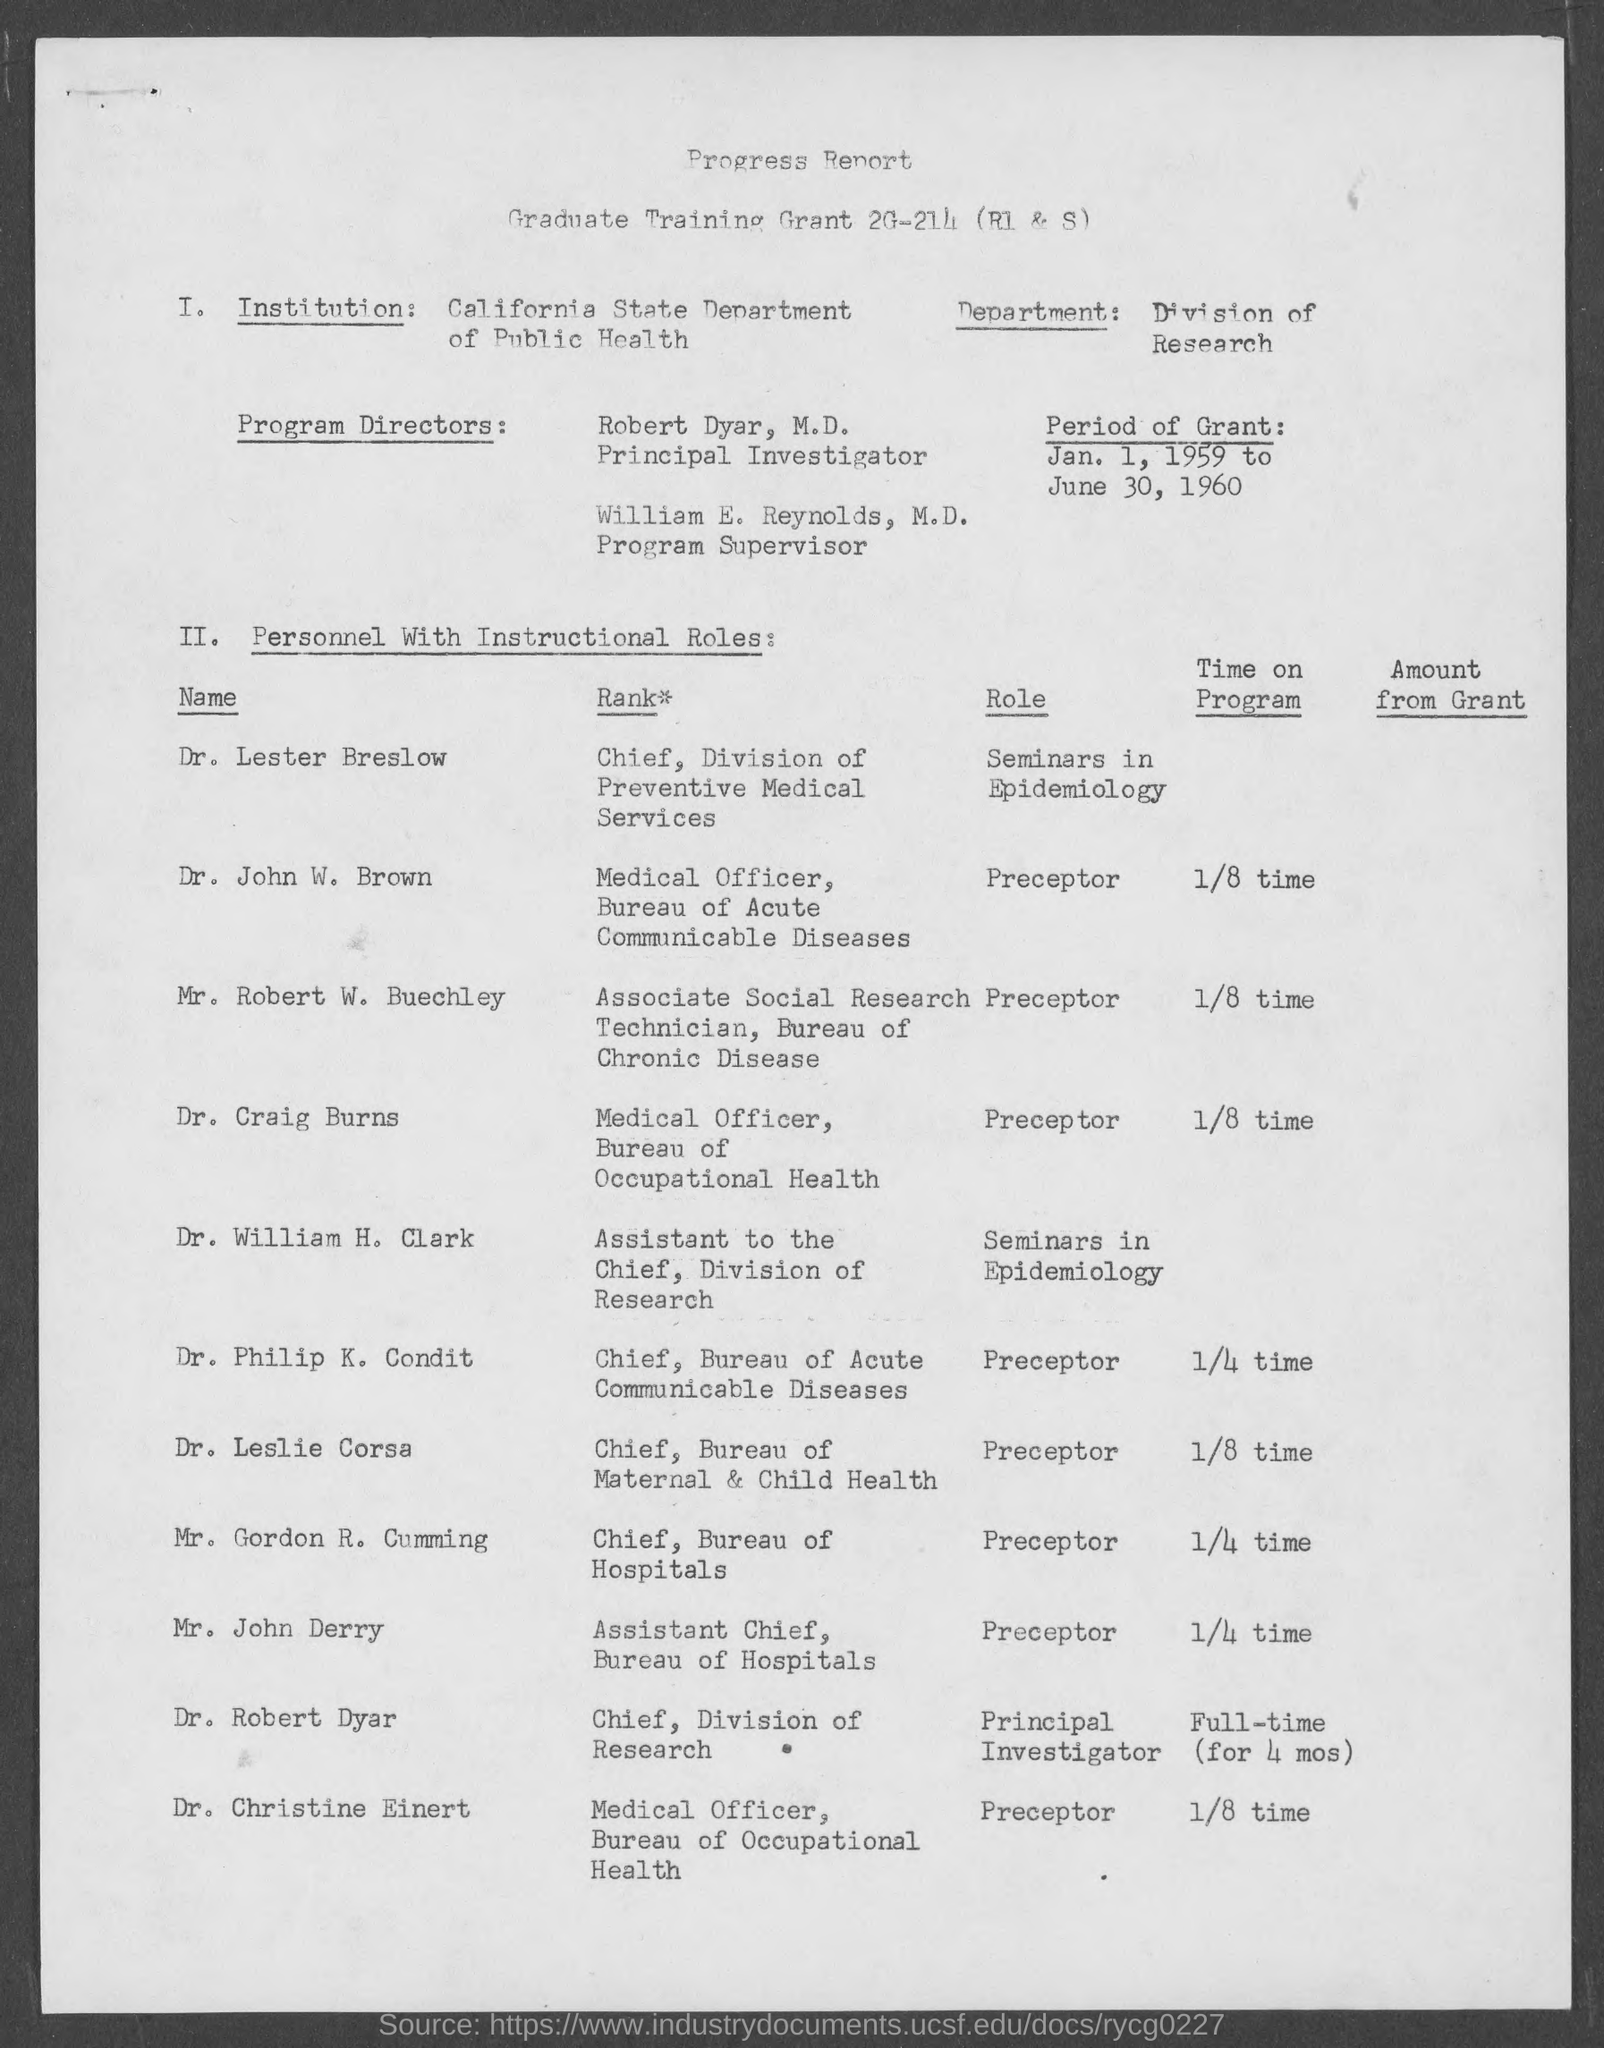Which institution is mentioned in this document?
Provide a succinct answer. CALIFORNIA STATE DEPARTMENT OF PUBLIC HEALTH. Which department is mentioned in this document?
Give a very brief answer. DIVISION OF RESEARCH. What is the period of Grant given in the document?
Your answer should be compact. JAN. 1, 1959 TO JUNE 30, 1960. Who is the Principal Investigator as per the document?
Ensure brevity in your answer.  ROBERT DYAR. Who is the Program Supervisor as per the document?
Your answer should be compact. WILLIAM E. REYNOLDS. What is the Rank of Dr. Lester Breslow?
Your response must be concise. CHIEF, DIVISION OF PREVENTIVE MEDICAL SERVICES. Who is the Medical Officer, Bureau of Acute Communicable Diseases?
Provide a succinct answer. DR. JOHN W. BROWN. What is the Role of Dr. Craig Burns as given in the document?
Offer a terse response. Preceptor. What is the Rank of Mr. John Derry?
Offer a very short reply. ASSISTANT CHIEF, BUREAU OF HOSPITALS. 